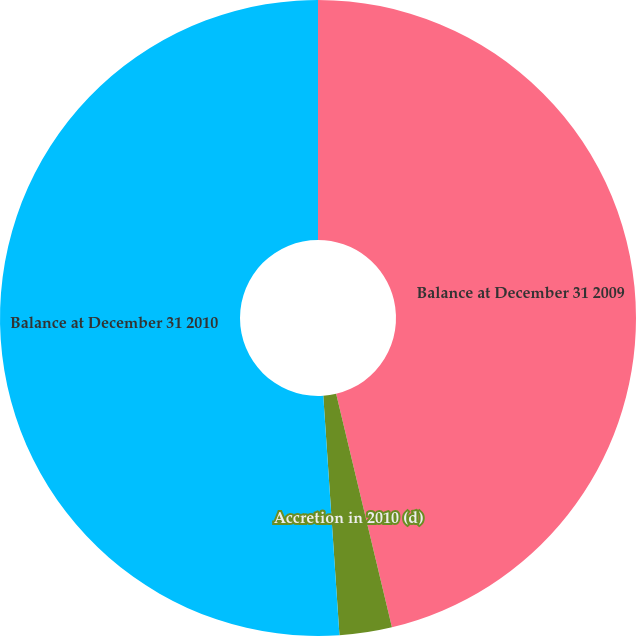Convert chart. <chart><loc_0><loc_0><loc_500><loc_500><pie_chart><fcel>Balance at December 31 2009<fcel>Accretion in 2010 (d)<fcel>Balance at December 31 2010<nl><fcel>46.27%<fcel>2.66%<fcel>51.08%<nl></chart> 